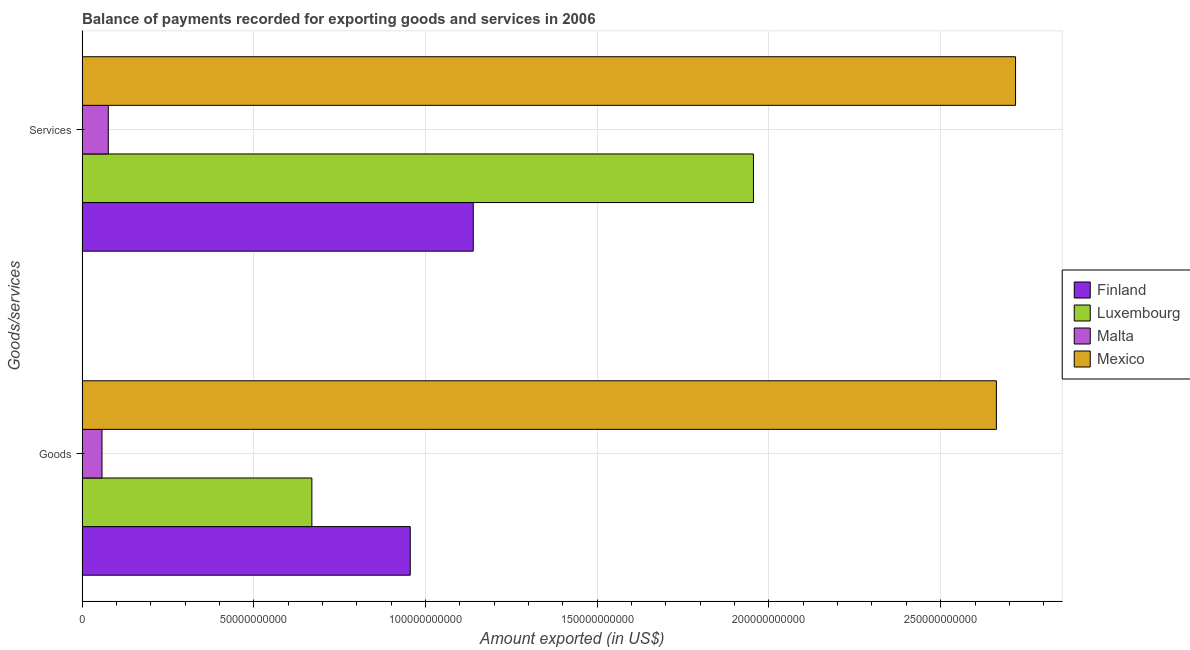How many groups of bars are there?
Keep it short and to the point. 2. Are the number of bars per tick equal to the number of legend labels?
Keep it short and to the point. Yes. How many bars are there on the 2nd tick from the bottom?
Ensure brevity in your answer.  4. What is the label of the 1st group of bars from the top?
Make the answer very short. Services. What is the amount of services exported in Finland?
Make the answer very short. 1.14e+11. Across all countries, what is the maximum amount of goods exported?
Your answer should be compact. 2.66e+11. Across all countries, what is the minimum amount of services exported?
Make the answer very short. 7.65e+09. In which country was the amount of goods exported maximum?
Your response must be concise. Mexico. In which country was the amount of services exported minimum?
Your answer should be compact. Malta. What is the total amount of services exported in the graph?
Offer a very short reply. 5.89e+11. What is the difference between the amount of services exported in Finland and that in Luxembourg?
Your response must be concise. -8.16e+1. What is the difference between the amount of goods exported in Finland and the amount of services exported in Luxembourg?
Your response must be concise. -9.99e+1. What is the average amount of services exported per country?
Offer a terse response. 1.47e+11. What is the difference between the amount of services exported and amount of goods exported in Malta?
Offer a very short reply. 1.84e+09. What is the ratio of the amount of goods exported in Luxembourg to that in Malta?
Give a very brief answer. 11.52. How many countries are there in the graph?
Your answer should be compact. 4. What is the difference between two consecutive major ticks on the X-axis?
Provide a short and direct response. 5.00e+1. Does the graph contain grids?
Make the answer very short. Yes. Where does the legend appear in the graph?
Your answer should be compact. Center right. How many legend labels are there?
Give a very brief answer. 4. How are the legend labels stacked?
Give a very brief answer. Vertical. What is the title of the graph?
Offer a very short reply. Balance of payments recorded for exporting goods and services in 2006. What is the label or title of the X-axis?
Provide a short and direct response. Amount exported (in US$). What is the label or title of the Y-axis?
Ensure brevity in your answer.  Goods/services. What is the Amount exported (in US$) of Finland in Goods?
Your answer should be compact. 9.56e+1. What is the Amount exported (in US$) of Luxembourg in Goods?
Your answer should be very brief. 6.69e+1. What is the Amount exported (in US$) of Malta in Goods?
Offer a terse response. 5.81e+09. What is the Amount exported (in US$) in Mexico in Goods?
Offer a terse response. 2.66e+11. What is the Amount exported (in US$) of Finland in Services?
Your answer should be compact. 1.14e+11. What is the Amount exported (in US$) in Luxembourg in Services?
Your answer should be compact. 1.95e+11. What is the Amount exported (in US$) in Malta in Services?
Your response must be concise. 7.65e+09. What is the Amount exported (in US$) of Mexico in Services?
Your response must be concise. 2.72e+11. Across all Goods/services, what is the maximum Amount exported (in US$) in Finland?
Give a very brief answer. 1.14e+11. Across all Goods/services, what is the maximum Amount exported (in US$) of Luxembourg?
Keep it short and to the point. 1.95e+11. Across all Goods/services, what is the maximum Amount exported (in US$) of Malta?
Offer a terse response. 7.65e+09. Across all Goods/services, what is the maximum Amount exported (in US$) in Mexico?
Offer a very short reply. 2.72e+11. Across all Goods/services, what is the minimum Amount exported (in US$) in Finland?
Ensure brevity in your answer.  9.56e+1. Across all Goods/services, what is the minimum Amount exported (in US$) of Luxembourg?
Your answer should be compact. 6.69e+1. Across all Goods/services, what is the minimum Amount exported (in US$) of Malta?
Make the answer very short. 5.81e+09. Across all Goods/services, what is the minimum Amount exported (in US$) in Mexico?
Make the answer very short. 2.66e+11. What is the total Amount exported (in US$) of Finland in the graph?
Offer a very short reply. 2.09e+11. What is the total Amount exported (in US$) of Luxembourg in the graph?
Offer a very short reply. 2.62e+11. What is the total Amount exported (in US$) of Malta in the graph?
Give a very brief answer. 1.35e+1. What is the total Amount exported (in US$) of Mexico in the graph?
Ensure brevity in your answer.  5.38e+11. What is the difference between the Amount exported (in US$) of Finland in Goods and that in Services?
Offer a very short reply. -1.83e+1. What is the difference between the Amount exported (in US$) in Luxembourg in Goods and that in Services?
Make the answer very short. -1.29e+11. What is the difference between the Amount exported (in US$) of Malta in Goods and that in Services?
Offer a very short reply. -1.84e+09. What is the difference between the Amount exported (in US$) in Mexico in Goods and that in Services?
Give a very brief answer. -5.58e+09. What is the difference between the Amount exported (in US$) in Finland in Goods and the Amount exported (in US$) in Luxembourg in Services?
Keep it short and to the point. -9.99e+1. What is the difference between the Amount exported (in US$) in Finland in Goods and the Amount exported (in US$) in Malta in Services?
Your answer should be compact. 8.79e+1. What is the difference between the Amount exported (in US$) of Finland in Goods and the Amount exported (in US$) of Mexico in Services?
Offer a very short reply. -1.76e+11. What is the difference between the Amount exported (in US$) of Luxembourg in Goods and the Amount exported (in US$) of Malta in Services?
Give a very brief answer. 5.93e+1. What is the difference between the Amount exported (in US$) in Luxembourg in Goods and the Amount exported (in US$) in Mexico in Services?
Ensure brevity in your answer.  -2.05e+11. What is the difference between the Amount exported (in US$) in Malta in Goods and the Amount exported (in US$) in Mexico in Services?
Your answer should be very brief. -2.66e+11. What is the average Amount exported (in US$) in Finland per Goods/services?
Make the answer very short. 1.05e+11. What is the average Amount exported (in US$) in Luxembourg per Goods/services?
Offer a very short reply. 1.31e+11. What is the average Amount exported (in US$) in Malta per Goods/services?
Keep it short and to the point. 6.73e+09. What is the average Amount exported (in US$) in Mexico per Goods/services?
Keep it short and to the point. 2.69e+11. What is the difference between the Amount exported (in US$) of Finland and Amount exported (in US$) of Luxembourg in Goods?
Your answer should be very brief. 2.86e+1. What is the difference between the Amount exported (in US$) in Finland and Amount exported (in US$) in Malta in Goods?
Give a very brief answer. 8.98e+1. What is the difference between the Amount exported (in US$) of Finland and Amount exported (in US$) of Mexico in Goods?
Provide a short and direct response. -1.71e+11. What is the difference between the Amount exported (in US$) in Luxembourg and Amount exported (in US$) in Malta in Goods?
Provide a short and direct response. 6.11e+1. What is the difference between the Amount exported (in US$) in Luxembourg and Amount exported (in US$) in Mexico in Goods?
Provide a succinct answer. -1.99e+11. What is the difference between the Amount exported (in US$) of Malta and Amount exported (in US$) of Mexico in Goods?
Your answer should be compact. -2.60e+11. What is the difference between the Amount exported (in US$) of Finland and Amount exported (in US$) of Luxembourg in Services?
Your answer should be compact. -8.16e+1. What is the difference between the Amount exported (in US$) of Finland and Amount exported (in US$) of Malta in Services?
Keep it short and to the point. 1.06e+11. What is the difference between the Amount exported (in US$) of Finland and Amount exported (in US$) of Mexico in Services?
Give a very brief answer. -1.58e+11. What is the difference between the Amount exported (in US$) of Luxembourg and Amount exported (in US$) of Malta in Services?
Your response must be concise. 1.88e+11. What is the difference between the Amount exported (in US$) in Luxembourg and Amount exported (in US$) in Mexico in Services?
Keep it short and to the point. -7.63e+1. What is the difference between the Amount exported (in US$) of Malta and Amount exported (in US$) of Mexico in Services?
Make the answer very short. -2.64e+11. What is the ratio of the Amount exported (in US$) in Finland in Goods to that in Services?
Make the answer very short. 0.84. What is the ratio of the Amount exported (in US$) in Luxembourg in Goods to that in Services?
Your answer should be compact. 0.34. What is the ratio of the Amount exported (in US$) in Malta in Goods to that in Services?
Keep it short and to the point. 0.76. What is the ratio of the Amount exported (in US$) in Mexico in Goods to that in Services?
Provide a succinct answer. 0.98. What is the difference between the highest and the second highest Amount exported (in US$) in Finland?
Your answer should be very brief. 1.83e+1. What is the difference between the highest and the second highest Amount exported (in US$) in Luxembourg?
Offer a very short reply. 1.29e+11. What is the difference between the highest and the second highest Amount exported (in US$) of Malta?
Your response must be concise. 1.84e+09. What is the difference between the highest and the second highest Amount exported (in US$) of Mexico?
Make the answer very short. 5.58e+09. What is the difference between the highest and the lowest Amount exported (in US$) in Finland?
Ensure brevity in your answer.  1.83e+1. What is the difference between the highest and the lowest Amount exported (in US$) of Luxembourg?
Your answer should be compact. 1.29e+11. What is the difference between the highest and the lowest Amount exported (in US$) of Malta?
Your response must be concise. 1.84e+09. What is the difference between the highest and the lowest Amount exported (in US$) of Mexico?
Provide a succinct answer. 5.58e+09. 